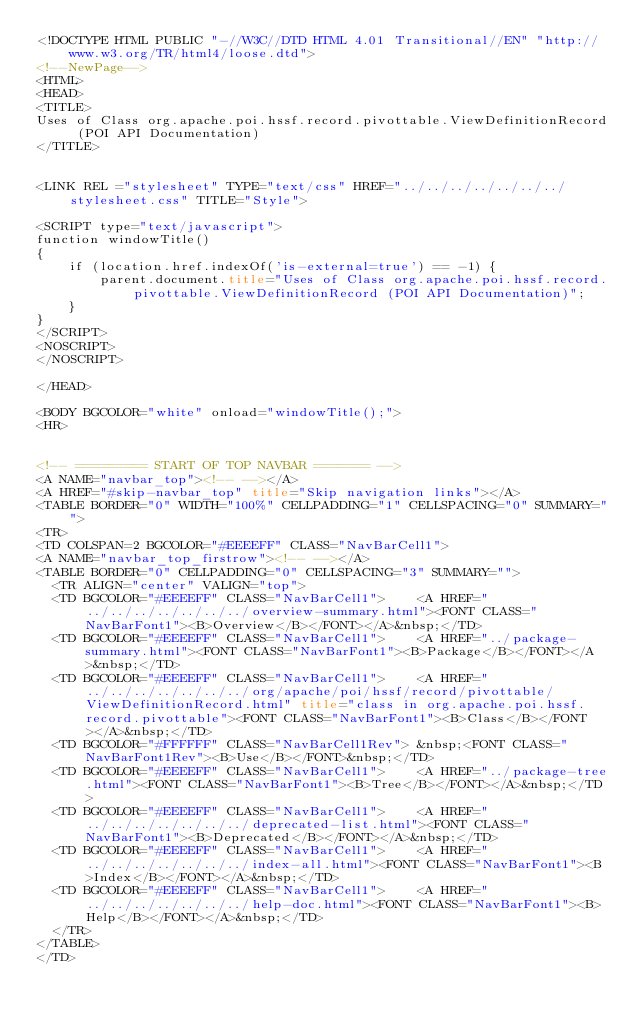<code> <loc_0><loc_0><loc_500><loc_500><_HTML_><!DOCTYPE HTML PUBLIC "-//W3C//DTD HTML 4.01 Transitional//EN" "http://www.w3.org/TR/html4/loose.dtd">
<!--NewPage-->
<HTML>
<HEAD>
<TITLE>
Uses of Class org.apache.poi.hssf.record.pivottable.ViewDefinitionRecord (POI API Documentation)
</TITLE>


<LINK REL ="stylesheet" TYPE="text/css" HREF="../../../../../../../stylesheet.css" TITLE="Style">

<SCRIPT type="text/javascript">
function windowTitle()
{
    if (location.href.indexOf('is-external=true') == -1) {
        parent.document.title="Uses of Class org.apache.poi.hssf.record.pivottable.ViewDefinitionRecord (POI API Documentation)";
    }
}
</SCRIPT>
<NOSCRIPT>
</NOSCRIPT>

</HEAD>

<BODY BGCOLOR="white" onload="windowTitle();">
<HR>


<!-- ========= START OF TOP NAVBAR ======= -->
<A NAME="navbar_top"><!-- --></A>
<A HREF="#skip-navbar_top" title="Skip navigation links"></A>
<TABLE BORDER="0" WIDTH="100%" CELLPADDING="1" CELLSPACING="0" SUMMARY="">
<TR>
<TD COLSPAN=2 BGCOLOR="#EEEEFF" CLASS="NavBarCell1">
<A NAME="navbar_top_firstrow"><!-- --></A>
<TABLE BORDER="0" CELLPADDING="0" CELLSPACING="3" SUMMARY="">
  <TR ALIGN="center" VALIGN="top">
  <TD BGCOLOR="#EEEEFF" CLASS="NavBarCell1">    <A HREF="../../../../../../../overview-summary.html"><FONT CLASS="NavBarFont1"><B>Overview</B></FONT></A>&nbsp;</TD>
  <TD BGCOLOR="#EEEEFF" CLASS="NavBarCell1">    <A HREF="../package-summary.html"><FONT CLASS="NavBarFont1"><B>Package</B></FONT></A>&nbsp;</TD>
  <TD BGCOLOR="#EEEEFF" CLASS="NavBarCell1">    <A HREF="../../../../../../../org/apache/poi/hssf/record/pivottable/ViewDefinitionRecord.html" title="class in org.apache.poi.hssf.record.pivottable"><FONT CLASS="NavBarFont1"><B>Class</B></FONT></A>&nbsp;</TD>
  <TD BGCOLOR="#FFFFFF" CLASS="NavBarCell1Rev"> &nbsp;<FONT CLASS="NavBarFont1Rev"><B>Use</B></FONT>&nbsp;</TD>
  <TD BGCOLOR="#EEEEFF" CLASS="NavBarCell1">    <A HREF="../package-tree.html"><FONT CLASS="NavBarFont1"><B>Tree</B></FONT></A>&nbsp;</TD>
  <TD BGCOLOR="#EEEEFF" CLASS="NavBarCell1">    <A HREF="../../../../../../../deprecated-list.html"><FONT CLASS="NavBarFont1"><B>Deprecated</B></FONT></A>&nbsp;</TD>
  <TD BGCOLOR="#EEEEFF" CLASS="NavBarCell1">    <A HREF="../../../../../../../index-all.html"><FONT CLASS="NavBarFont1"><B>Index</B></FONT></A>&nbsp;</TD>
  <TD BGCOLOR="#EEEEFF" CLASS="NavBarCell1">    <A HREF="../../../../../../../help-doc.html"><FONT CLASS="NavBarFont1"><B>Help</B></FONT></A>&nbsp;</TD>
  </TR>
</TABLE>
</TD></code> 